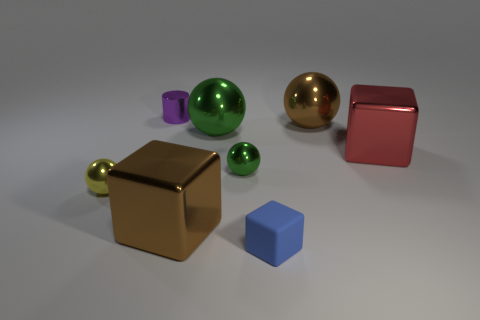How many other small blue rubber objects have the same shape as the tiny blue rubber object?
Ensure brevity in your answer.  0. There is a cube that is both to the right of the large green sphere and to the left of the large brown sphere; what is its material?
Give a very brief answer. Rubber. Are the tiny purple cylinder and the brown cube made of the same material?
Your answer should be very brief. Yes. How many small blue metal cylinders are there?
Make the answer very short. 0. What color is the large cube that is behind the big brown thing left of the green ball that is behind the large red block?
Your answer should be compact. Red. How many metal things are both to the right of the purple metallic object and to the left of the red shiny thing?
Your answer should be compact. 4. How many metallic things are spheres or brown spheres?
Give a very brief answer. 4. There is a object in front of the brown metal object in front of the big red block; what is it made of?
Ensure brevity in your answer.  Rubber. What is the shape of the yellow object that is the same size as the blue matte thing?
Ensure brevity in your answer.  Sphere. Is the number of small shiny objects less than the number of tiny rubber cylinders?
Your answer should be compact. No. 